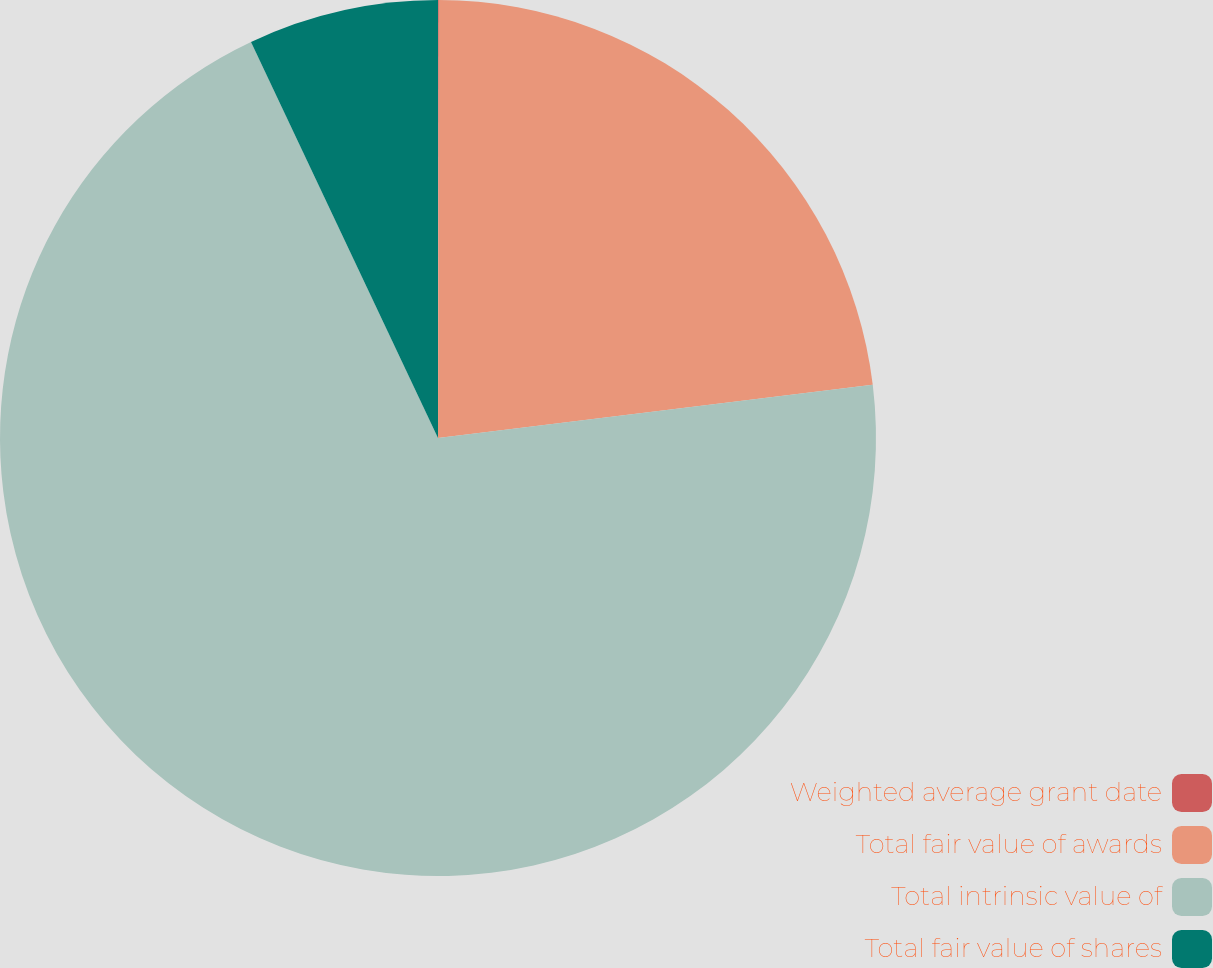Convert chart to OTSL. <chart><loc_0><loc_0><loc_500><loc_500><pie_chart><fcel>Weighted average grant date<fcel>Total fair value of awards<fcel>Total intrinsic value of<fcel>Total fair value of shares<nl><fcel>0.03%<fcel>23.03%<fcel>69.91%<fcel>7.02%<nl></chart> 